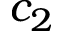<formula> <loc_0><loc_0><loc_500><loc_500>c _ { 2 }</formula> 